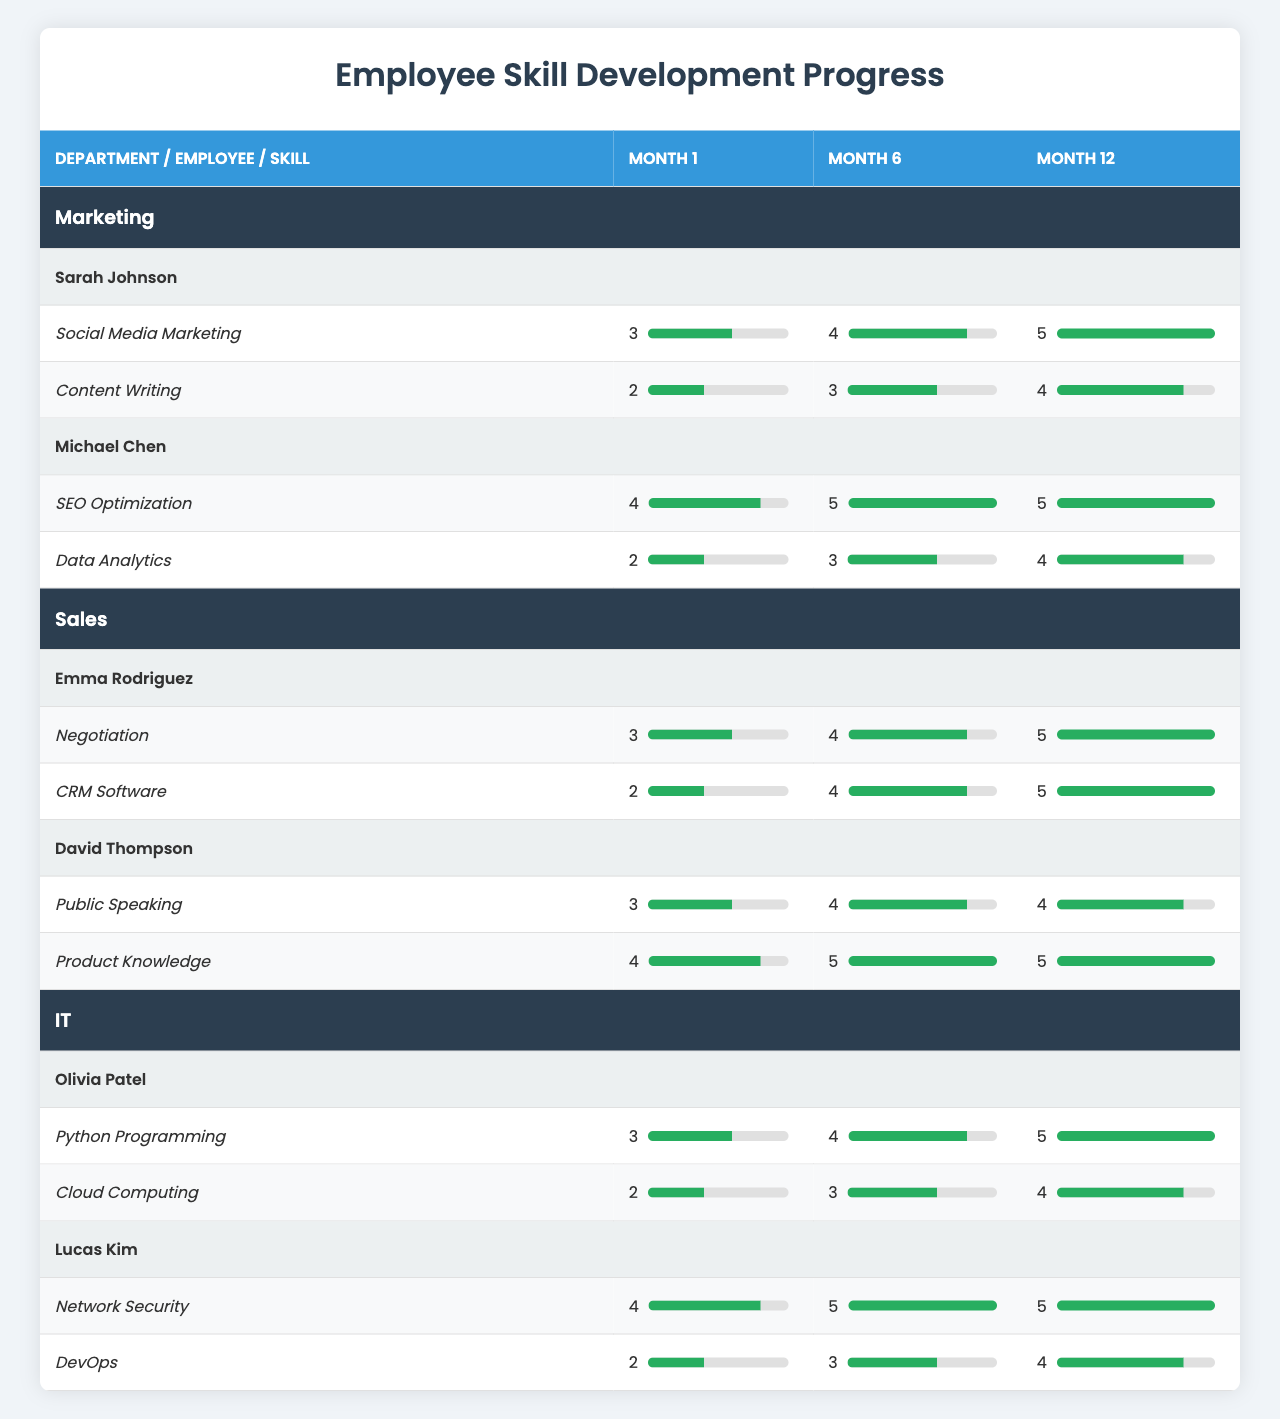What is the highest skill level achieved by Sarah Johnson in Social Media Marketing? Sarah Johnson's progress in Social Media Marketing shows levels of 3 (month 1), 4 (month 6), and 5 (month 12). The highest level is therefore 5.
Answer: 5 How many skills did Michael Chen improve in the first 6 months? Michael Chen has two skills: SEO Optimization (level 4 at month 1 to 5 at month 6) and Data Analytics (level 2 at month 1 to 3 at month 6). Both skills show improvement, so he improved in 2 skills.
Answer: 2 What was the level for Emma Rodriguez in CRM Software at month 1? In the table, Emma Rodriguez has a level of 2 for CRM Software at month 1 according to the skills progress listed.
Answer: 2 Is Lucas Kim's skill level for DevOps at month 12 higher than at month 1? Lucas Kim's skill level for DevOps is 2 at month 1 and 4 at month 12, indicating that it has indeed improved over the year.
Answer: Yes What is the average skill level of David Thompson at month 6? David Thompson has two skills: Public Speaking (level 4 at month 6) and Product Knowledge (level 5 at month 6). The average is (4 + 5) / 2 = 4.5.
Answer: 4.5 Who reached the highest skill level in the IT department? Olivia Patel's highest skill level for Python Programming is 5 at month 12, while Lucas Kim also reaches a level of 5 for Network Security at month 12. Hence, both achieved the highest level in IT.
Answer: Olivia Patel and Lucas Kim In which month did Emma Rodriguez achieve an equal skill level in both Negotiation and CRM Software? Emma Rodriguez achieved the same skill level of 4 in both skills at month 6, where Negotiation is at level 4 and CRM Software is also at level 4.
Answer: Month 6 What is the difference in skill level for Lucas Kim's Network Security between month 1 and month 12? Lucas Kim's skill level for Network Security is 4 at month 1 and stays at 5 at month 12, making the difference 5 - 4 = 1.
Answer: 1 Which employee has the highest overall skill level increase by month 12? Emily Rodriguez improved from levels of 3 to 5 in Negotiation (2 levels increase) and from 2 to 5 in CRM Software (3 levels increase). Thus, her overall increase is highest, totaling 5.
Answer: Emma Rodriguez Count the total number of skills across all employees at month 12. Each of the six employees has two skills, resulting in a total of 6 * 2 = 12 skills, leading to 12 skill levels to be counted for month 12.
Answer: 12 